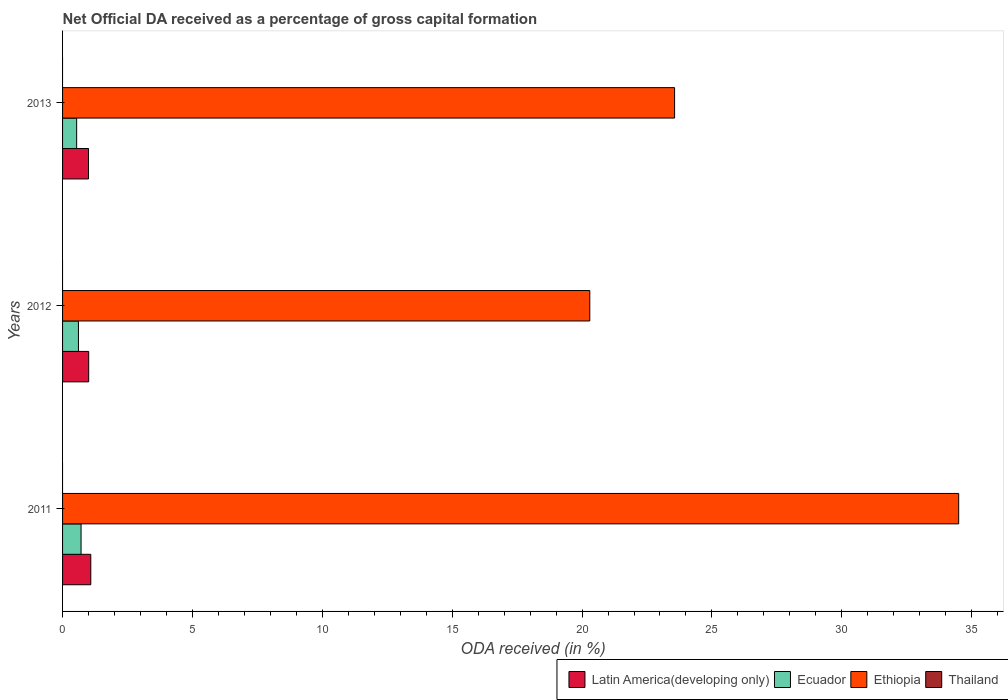How many different coloured bars are there?
Your answer should be compact. 3. How many groups of bars are there?
Give a very brief answer. 3. Are the number of bars on each tick of the Y-axis equal?
Give a very brief answer. Yes. How many bars are there on the 1st tick from the top?
Keep it short and to the point. 3. How many bars are there on the 2nd tick from the bottom?
Your response must be concise. 3. What is the label of the 1st group of bars from the top?
Offer a terse response. 2013. In how many cases, is the number of bars for a given year not equal to the number of legend labels?
Give a very brief answer. 3. What is the net ODA received in Ethiopia in 2013?
Your response must be concise. 23.56. Across all years, what is the maximum net ODA received in Ecuador?
Give a very brief answer. 0.71. Across all years, what is the minimum net ODA received in Ethiopia?
Ensure brevity in your answer.  20.3. In which year was the net ODA received in Latin America(developing only) maximum?
Keep it short and to the point. 2011. What is the total net ODA received in Ethiopia in the graph?
Your response must be concise. 78.36. What is the difference between the net ODA received in Ethiopia in 2012 and that in 2013?
Give a very brief answer. -3.26. What is the difference between the net ODA received in Ethiopia in 2011 and the net ODA received in Latin America(developing only) in 2012?
Offer a very short reply. 33.49. What is the average net ODA received in Ecuador per year?
Make the answer very short. 0.62. In the year 2013, what is the difference between the net ODA received in Ethiopia and net ODA received in Latin America(developing only)?
Offer a terse response. 22.56. In how many years, is the net ODA received in Thailand greater than 23 %?
Offer a very short reply. 0. What is the ratio of the net ODA received in Ethiopia in 2011 to that in 2013?
Your answer should be compact. 1.46. Is the difference between the net ODA received in Ethiopia in 2012 and 2013 greater than the difference between the net ODA received in Latin America(developing only) in 2012 and 2013?
Your response must be concise. No. What is the difference between the highest and the second highest net ODA received in Ethiopia?
Your response must be concise. 10.94. What is the difference between the highest and the lowest net ODA received in Ethiopia?
Ensure brevity in your answer.  14.2. In how many years, is the net ODA received in Thailand greater than the average net ODA received in Thailand taken over all years?
Keep it short and to the point. 0. Is it the case that in every year, the sum of the net ODA received in Thailand and net ODA received in Ethiopia is greater than the net ODA received in Ecuador?
Make the answer very short. Yes. What is the difference between two consecutive major ticks on the X-axis?
Make the answer very short. 5. Are the values on the major ticks of X-axis written in scientific E-notation?
Your answer should be compact. No. Where does the legend appear in the graph?
Provide a succinct answer. Bottom right. What is the title of the graph?
Provide a short and direct response. Net Official DA received as a percentage of gross capital formation. What is the label or title of the X-axis?
Provide a short and direct response. ODA received (in %). What is the ODA received (in %) of Latin America(developing only) in 2011?
Offer a very short reply. 1.09. What is the ODA received (in %) in Ecuador in 2011?
Provide a succinct answer. 0.71. What is the ODA received (in %) of Ethiopia in 2011?
Offer a terse response. 34.5. What is the ODA received (in %) in Latin America(developing only) in 2012?
Keep it short and to the point. 1.01. What is the ODA received (in %) of Ecuador in 2012?
Your answer should be compact. 0.61. What is the ODA received (in %) of Ethiopia in 2012?
Your answer should be compact. 20.3. What is the ODA received (in %) of Latin America(developing only) in 2013?
Your response must be concise. 1. What is the ODA received (in %) of Ecuador in 2013?
Your answer should be compact. 0.54. What is the ODA received (in %) in Ethiopia in 2013?
Give a very brief answer. 23.56. Across all years, what is the maximum ODA received (in %) in Latin America(developing only)?
Offer a very short reply. 1.09. Across all years, what is the maximum ODA received (in %) of Ecuador?
Make the answer very short. 0.71. Across all years, what is the maximum ODA received (in %) in Ethiopia?
Your answer should be very brief. 34.5. Across all years, what is the minimum ODA received (in %) of Latin America(developing only)?
Your answer should be compact. 1. Across all years, what is the minimum ODA received (in %) in Ecuador?
Give a very brief answer. 0.54. Across all years, what is the minimum ODA received (in %) of Ethiopia?
Make the answer very short. 20.3. What is the total ODA received (in %) of Latin America(developing only) in the graph?
Give a very brief answer. 3.09. What is the total ODA received (in %) in Ecuador in the graph?
Offer a very short reply. 1.87. What is the total ODA received (in %) of Ethiopia in the graph?
Offer a terse response. 78.36. What is the total ODA received (in %) of Thailand in the graph?
Keep it short and to the point. 0. What is the difference between the ODA received (in %) of Latin America(developing only) in 2011 and that in 2012?
Provide a succinct answer. 0.08. What is the difference between the ODA received (in %) of Ecuador in 2011 and that in 2012?
Provide a short and direct response. 0.1. What is the difference between the ODA received (in %) of Ethiopia in 2011 and that in 2012?
Keep it short and to the point. 14.2. What is the difference between the ODA received (in %) in Latin America(developing only) in 2011 and that in 2013?
Provide a succinct answer. 0.09. What is the difference between the ODA received (in %) of Ecuador in 2011 and that in 2013?
Ensure brevity in your answer.  0.17. What is the difference between the ODA received (in %) of Ethiopia in 2011 and that in 2013?
Provide a succinct answer. 10.94. What is the difference between the ODA received (in %) in Latin America(developing only) in 2012 and that in 2013?
Give a very brief answer. 0.01. What is the difference between the ODA received (in %) in Ecuador in 2012 and that in 2013?
Offer a very short reply. 0.07. What is the difference between the ODA received (in %) in Ethiopia in 2012 and that in 2013?
Keep it short and to the point. -3.26. What is the difference between the ODA received (in %) of Latin America(developing only) in 2011 and the ODA received (in %) of Ecuador in 2012?
Your response must be concise. 0.48. What is the difference between the ODA received (in %) in Latin America(developing only) in 2011 and the ODA received (in %) in Ethiopia in 2012?
Give a very brief answer. -19.21. What is the difference between the ODA received (in %) of Ecuador in 2011 and the ODA received (in %) of Ethiopia in 2012?
Your answer should be very brief. -19.59. What is the difference between the ODA received (in %) of Latin America(developing only) in 2011 and the ODA received (in %) of Ecuador in 2013?
Offer a very short reply. 0.54. What is the difference between the ODA received (in %) in Latin America(developing only) in 2011 and the ODA received (in %) in Ethiopia in 2013?
Keep it short and to the point. -22.48. What is the difference between the ODA received (in %) of Ecuador in 2011 and the ODA received (in %) of Ethiopia in 2013?
Your answer should be very brief. -22.85. What is the difference between the ODA received (in %) of Latin America(developing only) in 2012 and the ODA received (in %) of Ecuador in 2013?
Provide a short and direct response. 0.46. What is the difference between the ODA received (in %) of Latin America(developing only) in 2012 and the ODA received (in %) of Ethiopia in 2013?
Your answer should be very brief. -22.56. What is the difference between the ODA received (in %) in Ecuador in 2012 and the ODA received (in %) in Ethiopia in 2013?
Your answer should be compact. -22.95. What is the average ODA received (in %) of Latin America(developing only) per year?
Ensure brevity in your answer.  1.03. What is the average ODA received (in %) in Ecuador per year?
Ensure brevity in your answer.  0.62. What is the average ODA received (in %) in Ethiopia per year?
Ensure brevity in your answer.  26.12. In the year 2011, what is the difference between the ODA received (in %) in Latin America(developing only) and ODA received (in %) in Ecuador?
Offer a very short reply. 0.37. In the year 2011, what is the difference between the ODA received (in %) in Latin America(developing only) and ODA received (in %) in Ethiopia?
Provide a short and direct response. -33.41. In the year 2011, what is the difference between the ODA received (in %) of Ecuador and ODA received (in %) of Ethiopia?
Your answer should be very brief. -33.79. In the year 2012, what is the difference between the ODA received (in %) in Latin America(developing only) and ODA received (in %) in Ecuador?
Make the answer very short. 0.39. In the year 2012, what is the difference between the ODA received (in %) in Latin America(developing only) and ODA received (in %) in Ethiopia?
Offer a terse response. -19.29. In the year 2012, what is the difference between the ODA received (in %) of Ecuador and ODA received (in %) of Ethiopia?
Your answer should be compact. -19.69. In the year 2013, what is the difference between the ODA received (in %) in Latin America(developing only) and ODA received (in %) in Ecuador?
Provide a short and direct response. 0.46. In the year 2013, what is the difference between the ODA received (in %) in Latin America(developing only) and ODA received (in %) in Ethiopia?
Offer a very short reply. -22.56. In the year 2013, what is the difference between the ODA received (in %) in Ecuador and ODA received (in %) in Ethiopia?
Give a very brief answer. -23.02. What is the ratio of the ODA received (in %) of Latin America(developing only) in 2011 to that in 2012?
Make the answer very short. 1.08. What is the ratio of the ODA received (in %) in Ecuador in 2011 to that in 2012?
Provide a succinct answer. 1.16. What is the ratio of the ODA received (in %) in Ethiopia in 2011 to that in 2012?
Your answer should be very brief. 1.7. What is the ratio of the ODA received (in %) of Latin America(developing only) in 2011 to that in 2013?
Your response must be concise. 1.09. What is the ratio of the ODA received (in %) of Ecuador in 2011 to that in 2013?
Your answer should be compact. 1.31. What is the ratio of the ODA received (in %) in Ethiopia in 2011 to that in 2013?
Your answer should be very brief. 1.46. What is the ratio of the ODA received (in %) in Ecuador in 2012 to that in 2013?
Your answer should be compact. 1.13. What is the ratio of the ODA received (in %) of Ethiopia in 2012 to that in 2013?
Offer a very short reply. 0.86. What is the difference between the highest and the second highest ODA received (in %) in Latin America(developing only)?
Ensure brevity in your answer.  0.08. What is the difference between the highest and the second highest ODA received (in %) in Ecuador?
Give a very brief answer. 0.1. What is the difference between the highest and the second highest ODA received (in %) of Ethiopia?
Provide a short and direct response. 10.94. What is the difference between the highest and the lowest ODA received (in %) in Latin America(developing only)?
Give a very brief answer. 0.09. What is the difference between the highest and the lowest ODA received (in %) of Ecuador?
Keep it short and to the point. 0.17. What is the difference between the highest and the lowest ODA received (in %) of Ethiopia?
Offer a terse response. 14.2. 